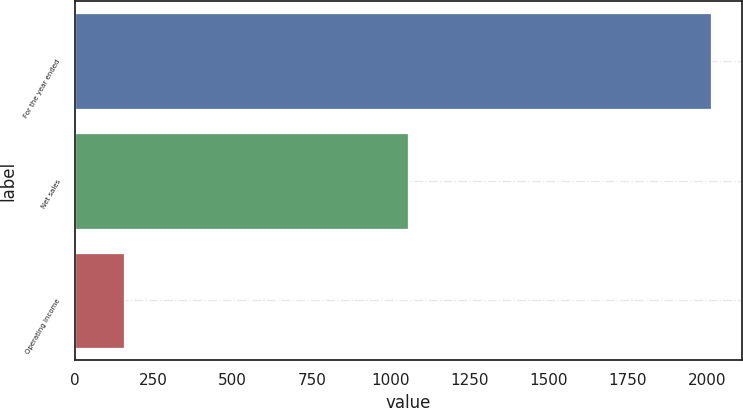Convert chart to OTSL. <chart><loc_0><loc_0><loc_500><loc_500><bar_chart><fcel>For the year ended<fcel>Net sales<fcel>Operating income<nl><fcel>2012<fcel>1054<fcel>156<nl></chart> 